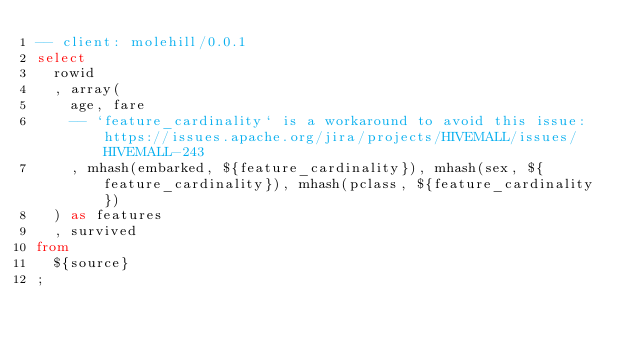<code> <loc_0><loc_0><loc_500><loc_500><_SQL_>-- client: molehill/0.0.1
select
  rowid
  , array(
    age, fare
    -- `feature_cardinality` is a workaround to avoid this issue: https://issues.apache.org/jira/projects/HIVEMALL/issues/HIVEMALL-243
    , mhash(embarked, ${feature_cardinality}), mhash(sex, ${feature_cardinality}), mhash(pclass, ${feature_cardinality})
  ) as features
  , survived
from
  ${source}
;
</code> 